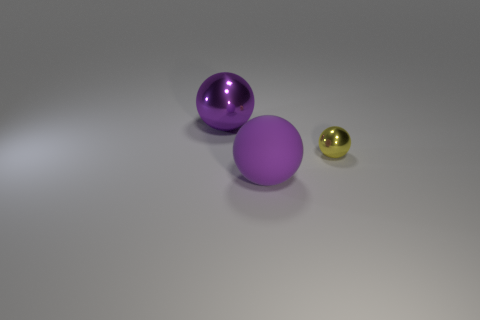Does the big metal object have the same color as the small shiny thing?
Provide a short and direct response. No. How many objects are left of the tiny thing and behind the large rubber ball?
Make the answer very short. 1. What number of small yellow shiny objects are the same shape as the large matte object?
Ensure brevity in your answer.  1. There is a big thing that is in front of the big purple metallic thing that is behind the tiny thing; what shape is it?
Your answer should be very brief. Sphere. What number of small yellow shiny spheres are in front of the large purple sphere in front of the big metal object?
Make the answer very short. 0. There is a object that is both in front of the big metallic thing and left of the small metallic sphere; what is its material?
Keep it short and to the point. Rubber. What is the shape of the thing that is the same size as the rubber sphere?
Make the answer very short. Sphere. What is the color of the big object in front of the large purple sphere that is behind the large ball on the right side of the purple metallic ball?
Give a very brief answer. Purple. How many things are things in front of the purple metal thing or matte balls?
Keep it short and to the point. 2. There is a sphere that is the same size as the purple shiny object; what is it made of?
Your answer should be very brief. Rubber. 